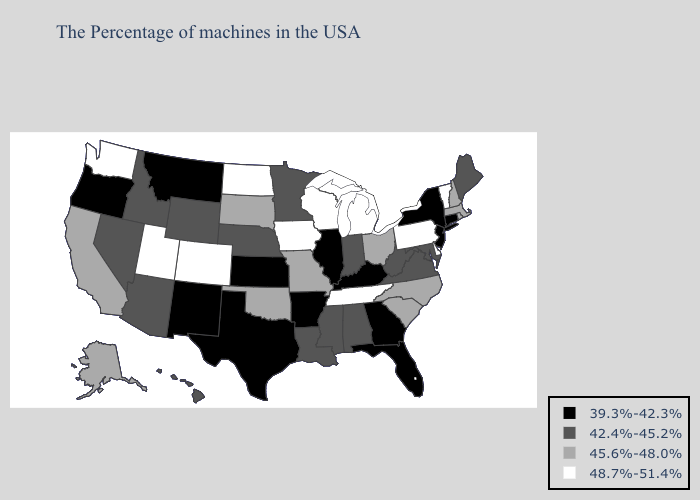What is the value of Kansas?
Concise answer only. 39.3%-42.3%. Does Indiana have the lowest value in the USA?
Answer briefly. No. Name the states that have a value in the range 45.6%-48.0%?
Short answer required. Massachusetts, Rhode Island, New Hampshire, North Carolina, South Carolina, Ohio, Missouri, Oklahoma, South Dakota, California, Alaska. Name the states that have a value in the range 42.4%-45.2%?
Be succinct. Maine, Maryland, Virginia, West Virginia, Indiana, Alabama, Mississippi, Louisiana, Minnesota, Nebraska, Wyoming, Arizona, Idaho, Nevada, Hawaii. Which states have the lowest value in the MidWest?
Write a very short answer. Illinois, Kansas. Which states hav the highest value in the MidWest?
Answer briefly. Michigan, Wisconsin, Iowa, North Dakota. Among the states that border Texas , which have the lowest value?
Concise answer only. Arkansas, New Mexico. Among the states that border New Jersey , does New York have the highest value?
Quick response, please. No. What is the lowest value in states that border North Carolina?
Concise answer only. 39.3%-42.3%. Among the states that border Louisiana , which have the lowest value?
Quick response, please. Arkansas, Texas. What is the highest value in the South ?
Be succinct. 48.7%-51.4%. What is the value of New York?
Answer briefly. 39.3%-42.3%. Name the states that have a value in the range 39.3%-42.3%?
Keep it brief. Connecticut, New York, New Jersey, Florida, Georgia, Kentucky, Illinois, Arkansas, Kansas, Texas, New Mexico, Montana, Oregon. Name the states that have a value in the range 48.7%-51.4%?
Concise answer only. Vermont, Delaware, Pennsylvania, Michigan, Tennessee, Wisconsin, Iowa, North Dakota, Colorado, Utah, Washington. What is the value of Michigan?
Concise answer only. 48.7%-51.4%. 